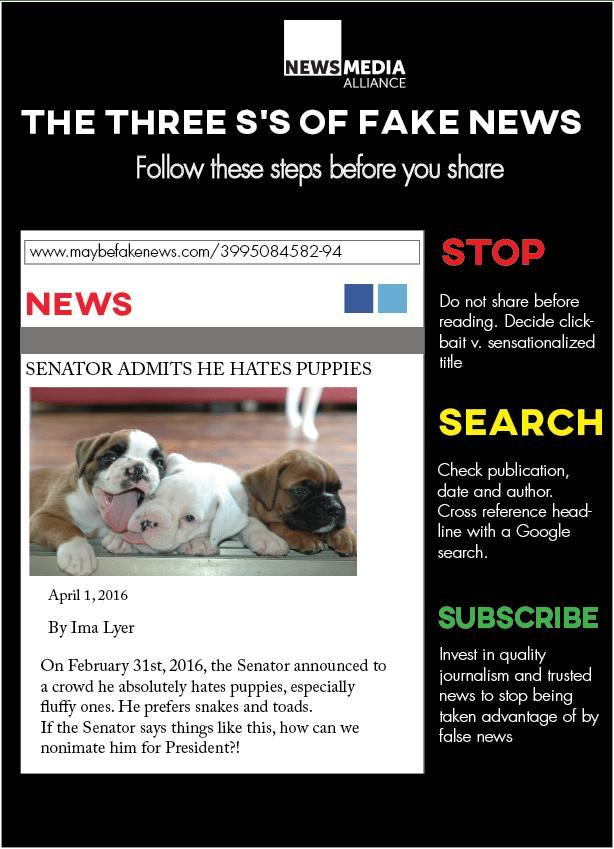what are the three s's of fake news given in this infographic?
Answer the question with a short phrase. stop, search, subscribe what is the color of the text of the main heading - white or black? white what is the color in which the sub heading "search" is written - red or yellow? yellow what is the color in which the sub heading "stop" is written - red or yellow? red 